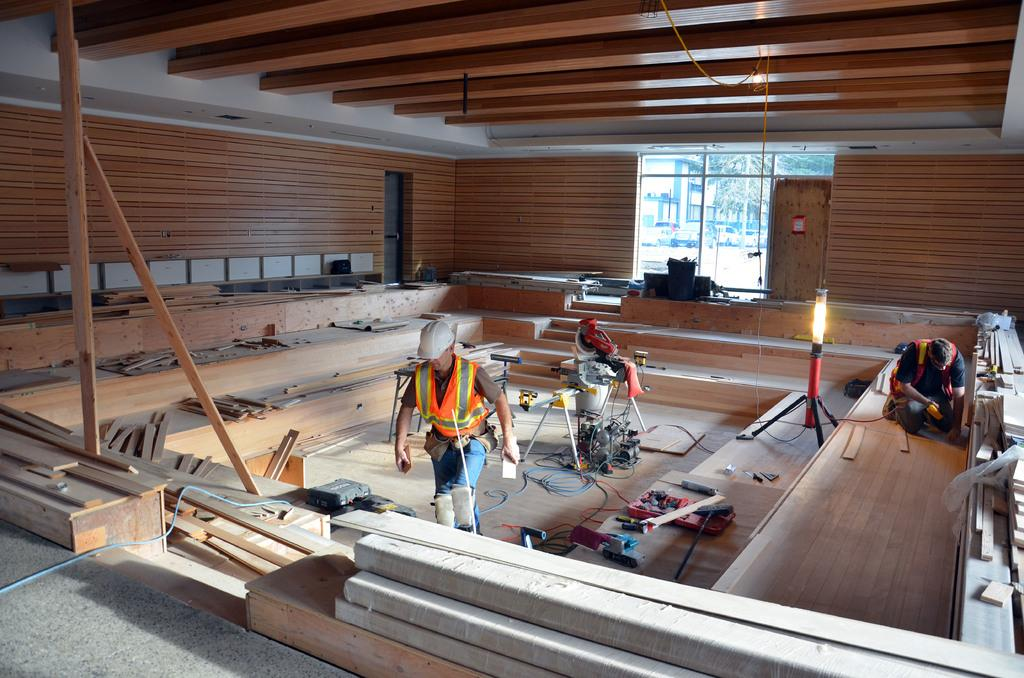How many persons are on the floor in the image? There are two persons on the floor in the image. What else can be seen in the image besides the persons? There are machines, a lamp stand, tools, a wall, a window, a door, and a rooftop in the image. What is the setting of the image? The image is taken in a hall. What is the tendency of the pipe in the image? There is no pipe present in the image. What type of club is featured in the image? There is no club present in the image. 